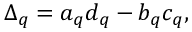Convert formula to latex. <formula><loc_0><loc_0><loc_500><loc_500>\Delta _ { q } = a _ { q } d _ { q } - b _ { q } c _ { q } ,</formula> 